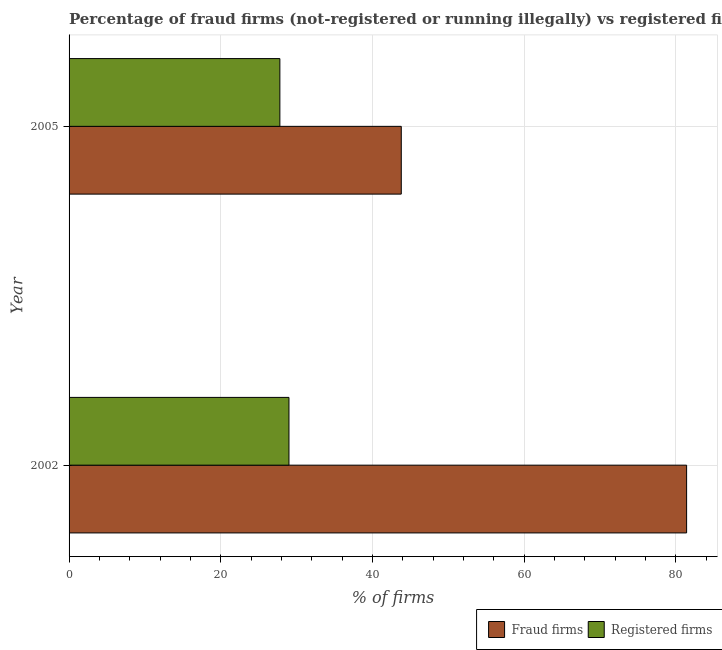How many different coloured bars are there?
Offer a very short reply. 2. Are the number of bars per tick equal to the number of legend labels?
Provide a short and direct response. Yes. How many bars are there on the 2nd tick from the top?
Your answer should be compact. 2. What is the label of the 2nd group of bars from the top?
Provide a short and direct response. 2002. What is the percentage of fraud firms in 2002?
Offer a terse response. 81.44. Across all years, what is the maximum percentage of fraud firms?
Your answer should be very brief. 81.44. Across all years, what is the minimum percentage of fraud firms?
Make the answer very short. 43.81. What is the total percentage of registered firms in the graph?
Provide a short and direct response. 56.8. What is the difference between the percentage of registered firms in 2002 and that in 2005?
Provide a succinct answer. 1.2. What is the difference between the percentage of registered firms in 2002 and the percentage of fraud firms in 2005?
Your response must be concise. -14.81. What is the average percentage of fraud firms per year?
Provide a succinct answer. 62.62. In the year 2005, what is the difference between the percentage of fraud firms and percentage of registered firms?
Keep it short and to the point. 16.01. In how many years, is the percentage of fraud firms greater than 48 %?
Keep it short and to the point. 1. What is the ratio of the percentage of registered firms in 2002 to that in 2005?
Offer a very short reply. 1.04. Is the percentage of registered firms in 2002 less than that in 2005?
Keep it short and to the point. No. Is the difference between the percentage of registered firms in 2002 and 2005 greater than the difference between the percentage of fraud firms in 2002 and 2005?
Provide a succinct answer. No. In how many years, is the percentage of registered firms greater than the average percentage of registered firms taken over all years?
Make the answer very short. 1. What does the 2nd bar from the top in 2002 represents?
Ensure brevity in your answer.  Fraud firms. What does the 2nd bar from the bottom in 2002 represents?
Your response must be concise. Registered firms. How many years are there in the graph?
Ensure brevity in your answer.  2. What is the difference between two consecutive major ticks on the X-axis?
Provide a succinct answer. 20. Are the values on the major ticks of X-axis written in scientific E-notation?
Provide a short and direct response. No. How many legend labels are there?
Your answer should be very brief. 2. How are the legend labels stacked?
Offer a very short reply. Horizontal. What is the title of the graph?
Ensure brevity in your answer.  Percentage of fraud firms (not-registered or running illegally) vs registered firms in Georgia. What is the label or title of the X-axis?
Offer a terse response. % of firms. What is the % of firms of Fraud firms in 2002?
Give a very brief answer. 81.44. What is the % of firms of Fraud firms in 2005?
Provide a succinct answer. 43.81. What is the % of firms in Registered firms in 2005?
Make the answer very short. 27.8. Across all years, what is the maximum % of firms of Fraud firms?
Offer a very short reply. 81.44. Across all years, what is the minimum % of firms of Fraud firms?
Your answer should be compact. 43.81. Across all years, what is the minimum % of firms in Registered firms?
Give a very brief answer. 27.8. What is the total % of firms of Fraud firms in the graph?
Offer a very short reply. 125.25. What is the total % of firms in Registered firms in the graph?
Offer a very short reply. 56.8. What is the difference between the % of firms in Fraud firms in 2002 and that in 2005?
Provide a succinct answer. 37.63. What is the difference between the % of firms in Fraud firms in 2002 and the % of firms in Registered firms in 2005?
Make the answer very short. 53.64. What is the average % of firms of Fraud firms per year?
Offer a terse response. 62.62. What is the average % of firms in Registered firms per year?
Ensure brevity in your answer.  28.4. In the year 2002, what is the difference between the % of firms in Fraud firms and % of firms in Registered firms?
Offer a very short reply. 52.44. In the year 2005, what is the difference between the % of firms in Fraud firms and % of firms in Registered firms?
Your answer should be very brief. 16.01. What is the ratio of the % of firms of Fraud firms in 2002 to that in 2005?
Your answer should be very brief. 1.86. What is the ratio of the % of firms in Registered firms in 2002 to that in 2005?
Make the answer very short. 1.04. What is the difference between the highest and the second highest % of firms of Fraud firms?
Provide a short and direct response. 37.63. What is the difference between the highest and the second highest % of firms of Registered firms?
Your response must be concise. 1.2. What is the difference between the highest and the lowest % of firms in Fraud firms?
Your answer should be compact. 37.63. What is the difference between the highest and the lowest % of firms of Registered firms?
Keep it short and to the point. 1.2. 